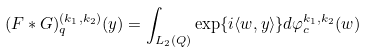Convert formula to latex. <formula><loc_0><loc_0><loc_500><loc_500>( F * G ) _ { q } ^ { ( k _ { 1 } , k _ { 2 } ) } ( y ) = \int _ { L _ { 2 } ( Q ) } \exp \{ i \langle { w , y } \rangle \} d \varphi ^ { k _ { 1 } , k _ { 2 } } _ { c } ( w )</formula> 